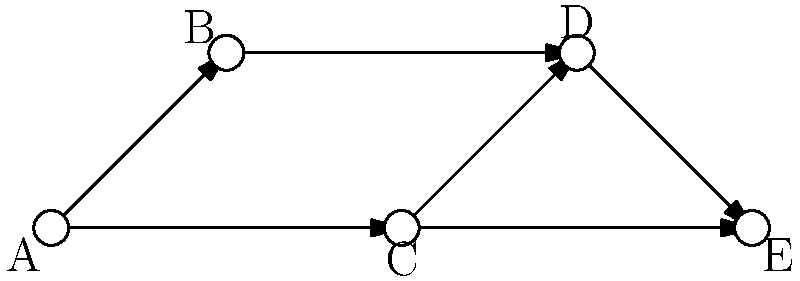In the network graph representing cultural diffusion patterns across societies, what is the minimum number of societies a cultural element must pass through to diffuse from society A to society E? To solve this problem, we need to analyze the paths from society A to society E in the network graph. Let's break it down step-by-step:

1. First, identify all possible paths from A to E:
   - Path 1: A → B → D → E
   - Path 2: A → C → D → E
   - Path 3: A → C → E

2. Count the number of societies (nodes) in each path:
   - Path 1: 4 societies (A, B, D, E)
   - Path 2: 4 societies (A, C, D, E)
   - Path 3: 3 societies (A, C, E)

3. The question asks for the minimum number of societies, so we need to find the shortest path.

4. The shortest path is Path 3: A → C → E, which includes 3 societies.

5. To calculate the number of societies a cultural element must pass through, we subtract 1 from the total number of societies in the path (as we don't count the starting society).

Therefore, the minimum number of societies a cultural element must pass through to diffuse from society A to society E is 3 - 1 = 2.
Answer: 2 